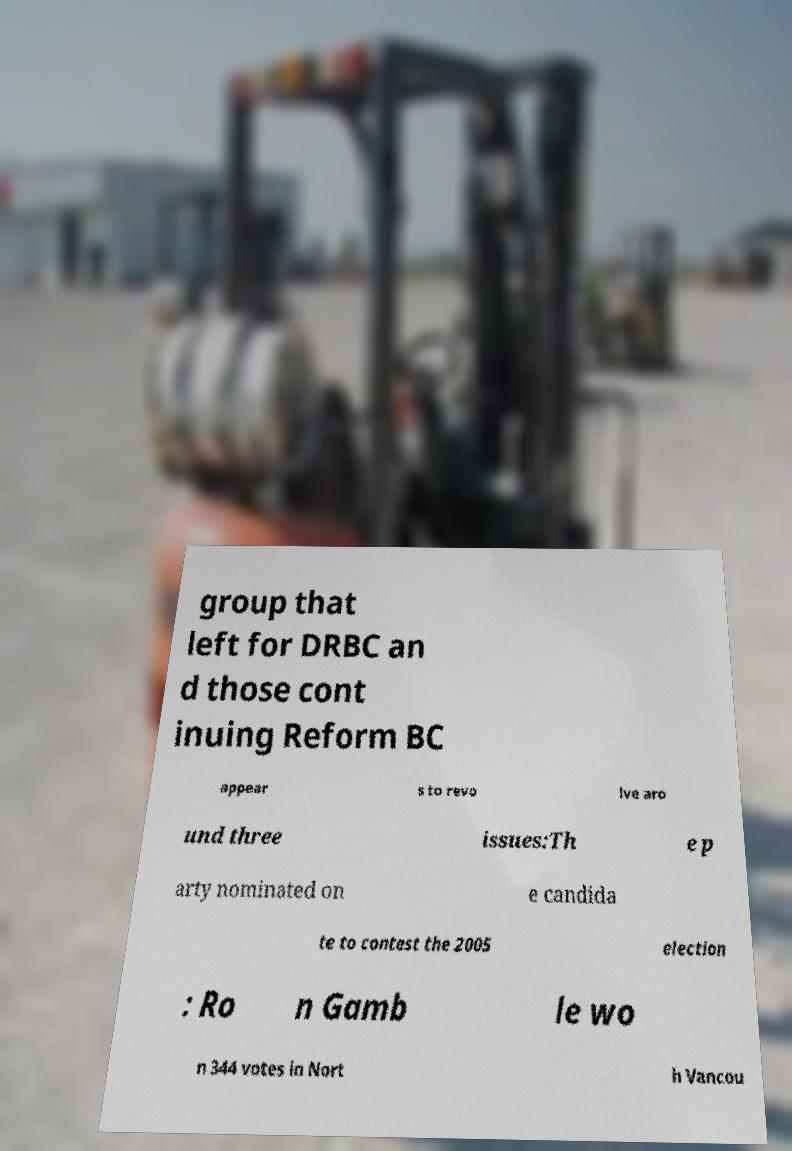I need the written content from this picture converted into text. Can you do that? group that left for DRBC an d those cont inuing Reform BC appear s to revo lve aro und three issues:Th e p arty nominated on e candida te to contest the 2005 election : Ro n Gamb le wo n 344 votes in Nort h Vancou 